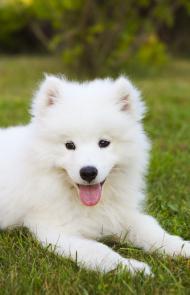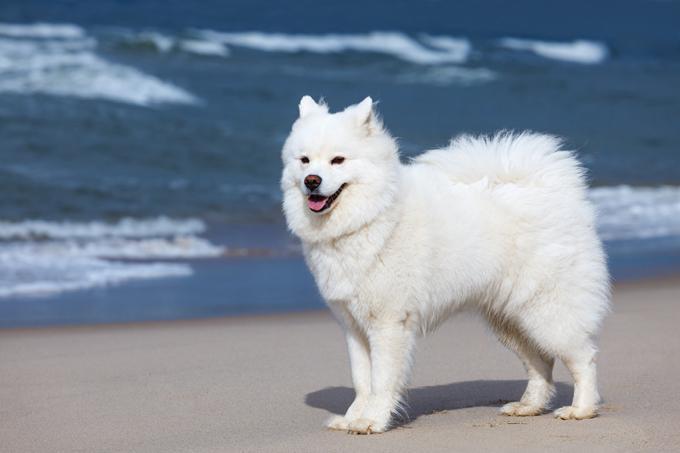The first image is the image on the left, the second image is the image on the right. Examine the images to the left and right. Is the description "The dog on the right is facing right." accurate? Answer yes or no. No. 